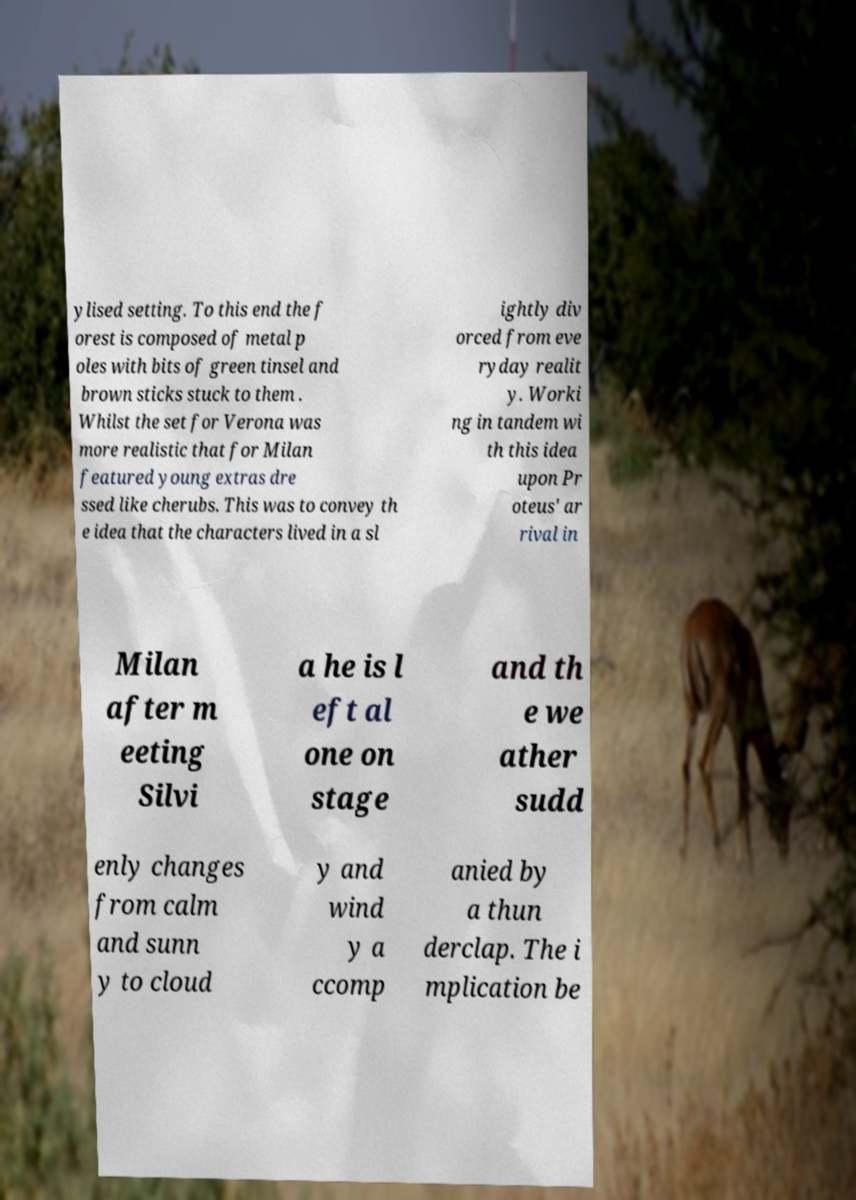Can you read and provide the text displayed in the image?This photo seems to have some interesting text. Can you extract and type it out for me? ylised setting. To this end the f orest is composed of metal p oles with bits of green tinsel and brown sticks stuck to them . Whilst the set for Verona was more realistic that for Milan featured young extras dre ssed like cherubs. This was to convey th e idea that the characters lived in a sl ightly div orced from eve ryday realit y. Worki ng in tandem wi th this idea upon Pr oteus' ar rival in Milan after m eeting Silvi a he is l eft al one on stage and th e we ather sudd enly changes from calm and sunn y to cloud y and wind y a ccomp anied by a thun derclap. The i mplication be 